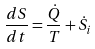Convert formula to latex. <formula><loc_0><loc_0><loc_500><loc_500>\frac { d S } { d t } = \frac { \dot { Q } } { T } + \dot { S } _ { i }</formula> 